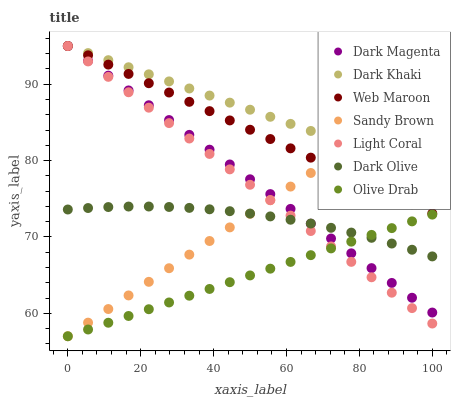Does Olive Drab have the minimum area under the curve?
Answer yes or no. Yes. Does Dark Khaki have the maximum area under the curve?
Answer yes or no. Yes. Does Dark Magenta have the minimum area under the curve?
Answer yes or no. No. Does Dark Magenta have the maximum area under the curve?
Answer yes or no. No. Is Light Coral the smoothest?
Answer yes or no. Yes. Is Dark Olive the roughest?
Answer yes or no. Yes. Is Dark Magenta the smoothest?
Answer yes or no. No. Is Dark Magenta the roughest?
Answer yes or no. No. Does Sandy Brown have the lowest value?
Answer yes or no. Yes. Does Dark Magenta have the lowest value?
Answer yes or no. No. Does Dark Khaki have the highest value?
Answer yes or no. Yes. Does Dark Olive have the highest value?
Answer yes or no. No. Is Olive Drab less than Dark Khaki?
Answer yes or no. Yes. Is Web Maroon greater than Dark Olive?
Answer yes or no. Yes. Does Dark Khaki intersect Light Coral?
Answer yes or no. Yes. Is Dark Khaki less than Light Coral?
Answer yes or no. No. Is Dark Khaki greater than Light Coral?
Answer yes or no. No. Does Olive Drab intersect Dark Khaki?
Answer yes or no. No. 